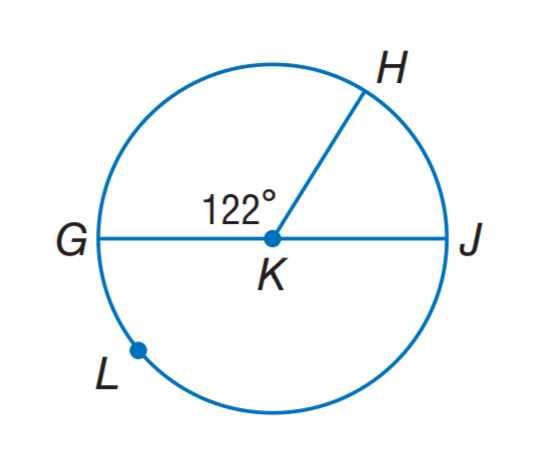Answer the mathemtical geometry problem and directly provide the correct option letter.
Question: G J is a diameter of \odot K. Find m \widehat G L H.
Choices: A: 119 B: 122 C: 238 D: 244 C 